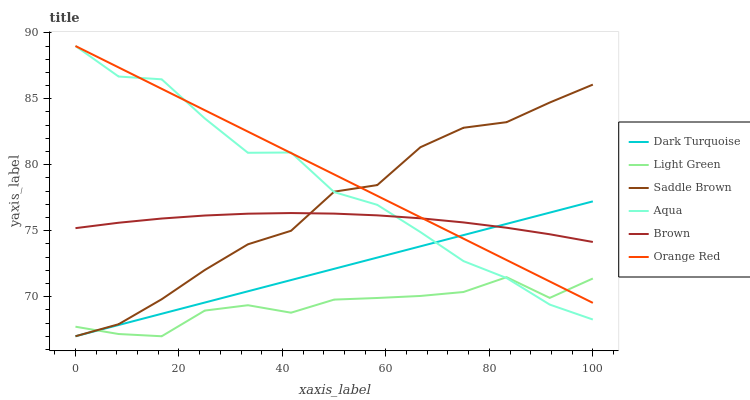Does Light Green have the minimum area under the curve?
Answer yes or no. Yes. Does Orange Red have the maximum area under the curve?
Answer yes or no. Yes. Does Dark Turquoise have the minimum area under the curve?
Answer yes or no. No. Does Dark Turquoise have the maximum area under the curve?
Answer yes or no. No. Is Orange Red the smoothest?
Answer yes or no. Yes. Is Aqua the roughest?
Answer yes or no. Yes. Is Dark Turquoise the smoothest?
Answer yes or no. No. Is Dark Turquoise the roughest?
Answer yes or no. No. Does Dark Turquoise have the lowest value?
Answer yes or no. Yes. Does Aqua have the lowest value?
Answer yes or no. No. Does Orange Red have the highest value?
Answer yes or no. Yes. Does Dark Turquoise have the highest value?
Answer yes or no. No. Is Light Green less than Brown?
Answer yes or no. Yes. Is Brown greater than Light Green?
Answer yes or no. Yes. Does Aqua intersect Light Green?
Answer yes or no. Yes. Is Aqua less than Light Green?
Answer yes or no. No. Is Aqua greater than Light Green?
Answer yes or no. No. Does Light Green intersect Brown?
Answer yes or no. No. 